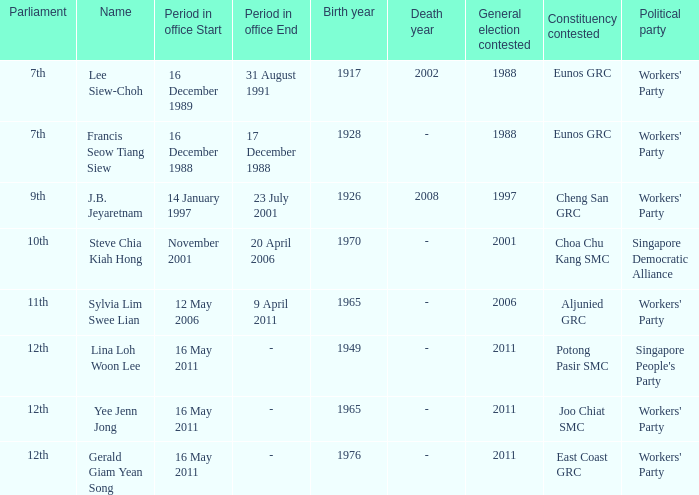In which parliament does lina loh woon lee hold membership? 12th. 